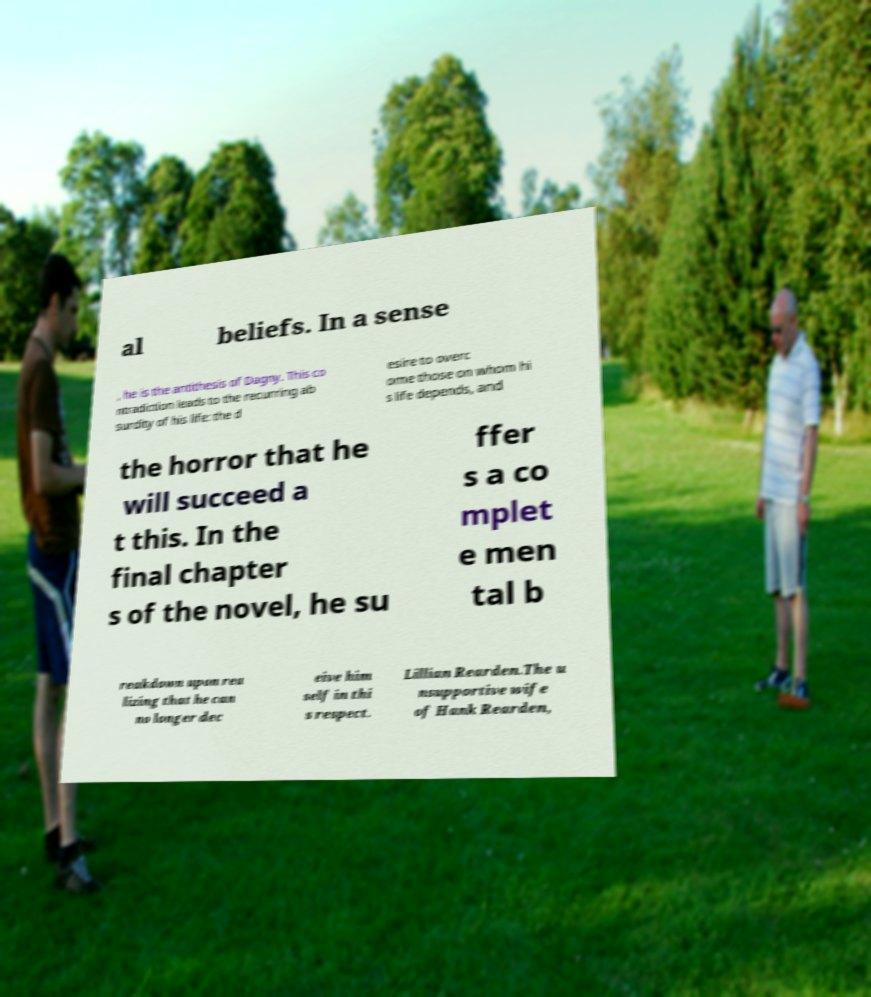Could you extract and type out the text from this image? al beliefs. In a sense , he is the antithesis of Dagny. This co ntradiction leads to the recurring ab surdity of his life: the d esire to overc ome those on whom hi s life depends, and the horror that he will succeed a t this. In the final chapter s of the novel, he su ffer s a co mplet e men tal b reakdown upon rea lizing that he can no longer dec eive him self in thi s respect. Lillian Rearden.The u nsupportive wife of Hank Rearden, 